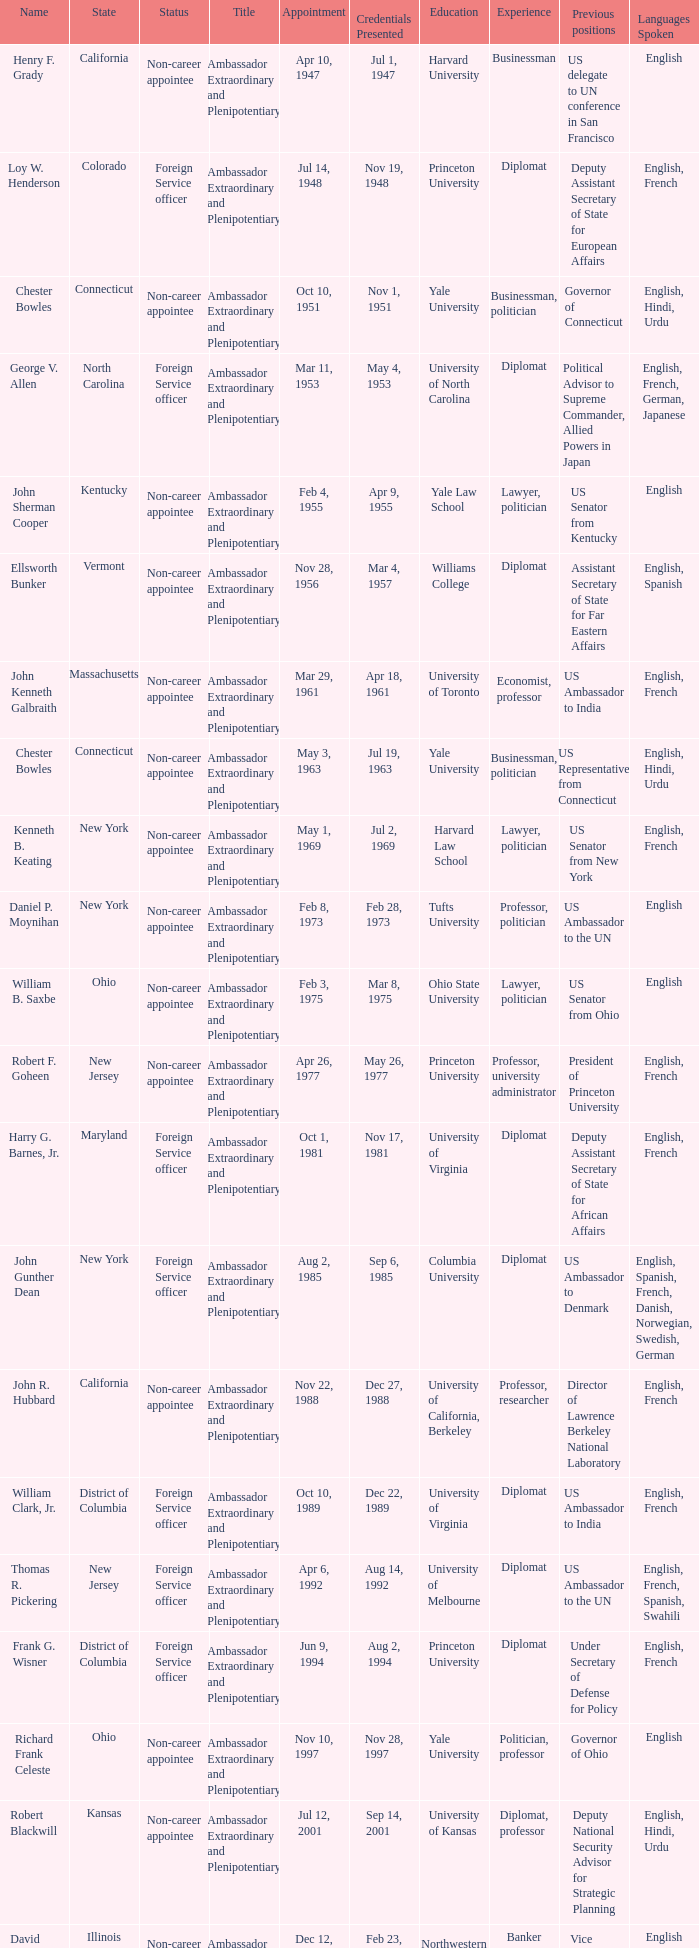When were the credentials presented for new jersey with a status of foreign service officer? Aug 14, 1992. 